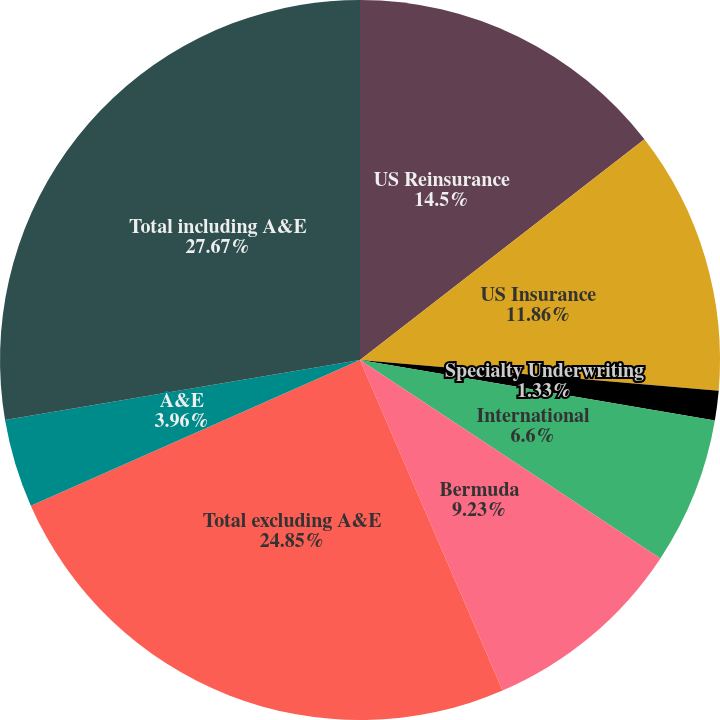Convert chart. <chart><loc_0><loc_0><loc_500><loc_500><pie_chart><fcel>US Reinsurance<fcel>US Insurance<fcel>Specialty Underwriting<fcel>International<fcel>Bermuda<fcel>Total excluding A&E<fcel>A&E<fcel>Total including A&E<nl><fcel>14.5%<fcel>11.86%<fcel>1.33%<fcel>6.6%<fcel>9.23%<fcel>24.85%<fcel>3.96%<fcel>27.67%<nl></chart> 